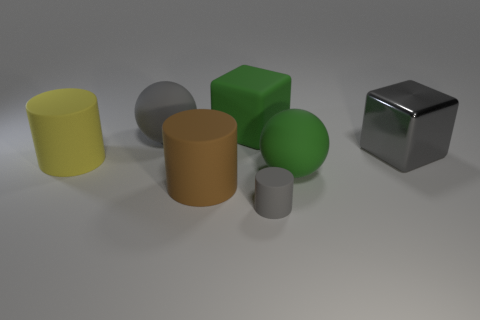What is the material of the yellow object that is the same shape as the tiny gray object?
Your answer should be compact. Rubber. There is a large cube to the left of the big green matte thing that is in front of the big gray thing that is in front of the gray sphere; what is its color?
Offer a very short reply. Green. How many objects are gray objects or large yellow cylinders?
Your answer should be compact. 4. What number of blue matte objects are the same shape as the big brown rubber object?
Your response must be concise. 0. Are the large yellow thing and the gray thing in front of the large yellow rubber cylinder made of the same material?
Your response must be concise. Yes. There is a block that is the same material as the tiny gray thing; what size is it?
Your answer should be very brief. Large. How big is the rubber cylinder that is to the right of the large brown rubber object?
Your answer should be very brief. Small. How many gray rubber cylinders have the same size as the yellow cylinder?
Provide a short and direct response. 0. There is a matte sphere that is the same color as the tiny object; what size is it?
Your answer should be compact. Large. Is there a small matte cube that has the same color as the metallic thing?
Keep it short and to the point. No. 